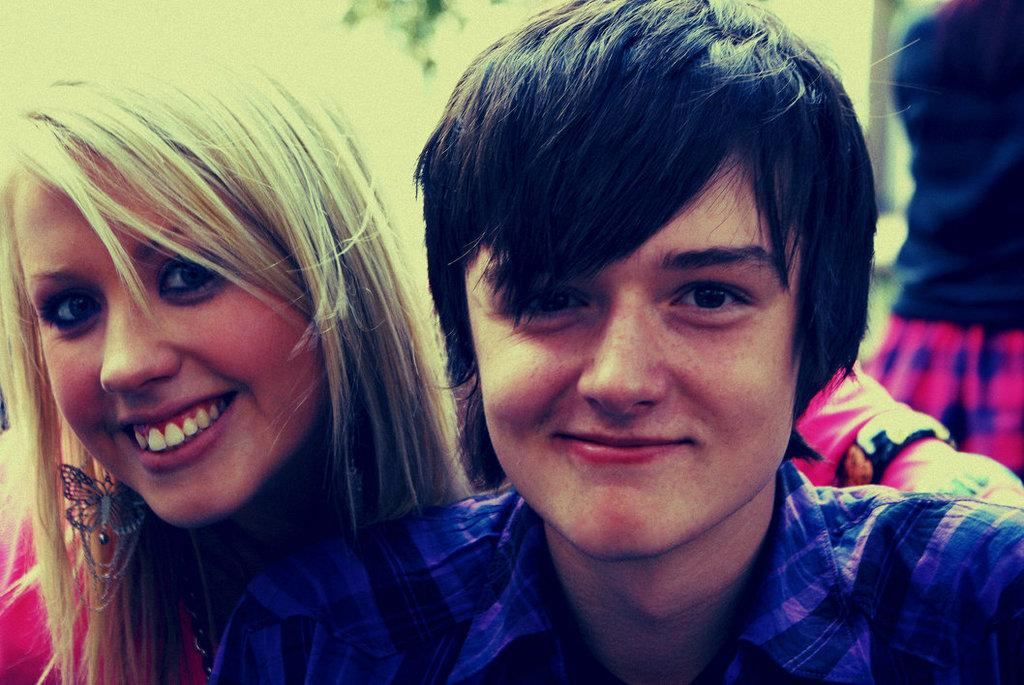Who or what can be seen in the image? There are people in the image. Can you describe the position of the people in the image? The people are standing in front. What type of copper material is being used to make a quilt in the image? There is no copper or quilt present in the image; it only features people standing in front. 